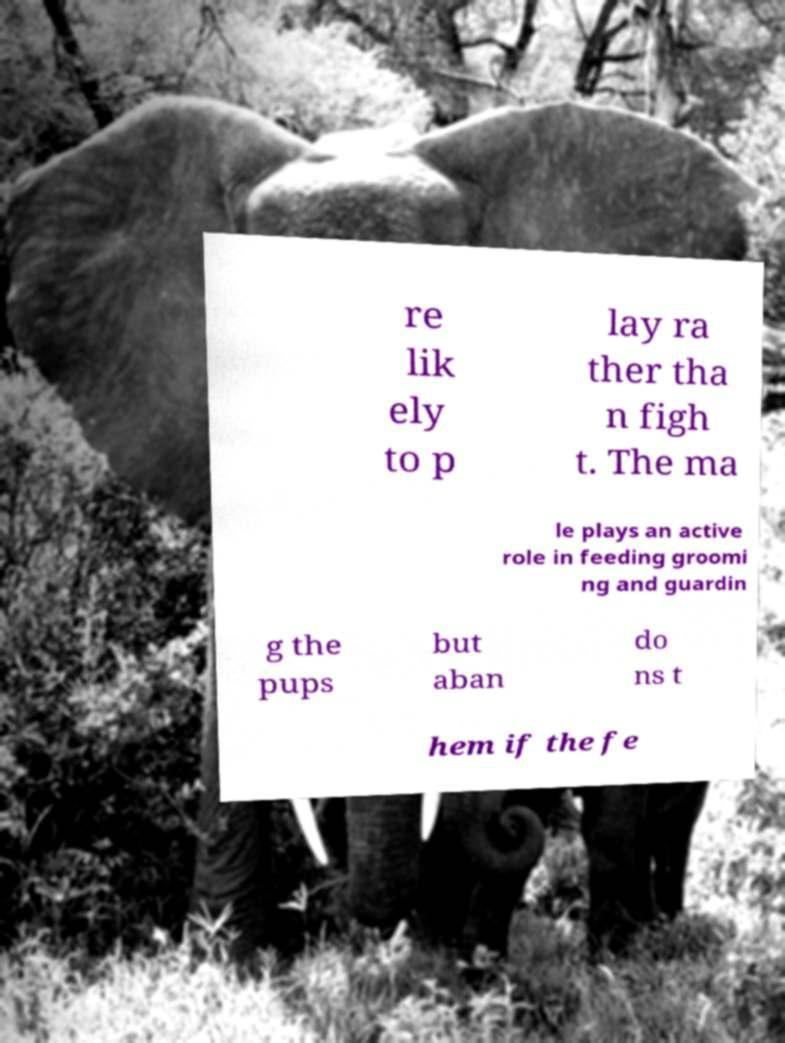Please identify and transcribe the text found in this image. re lik ely to p lay ra ther tha n figh t. The ma le plays an active role in feeding groomi ng and guardin g the pups but aban do ns t hem if the fe 